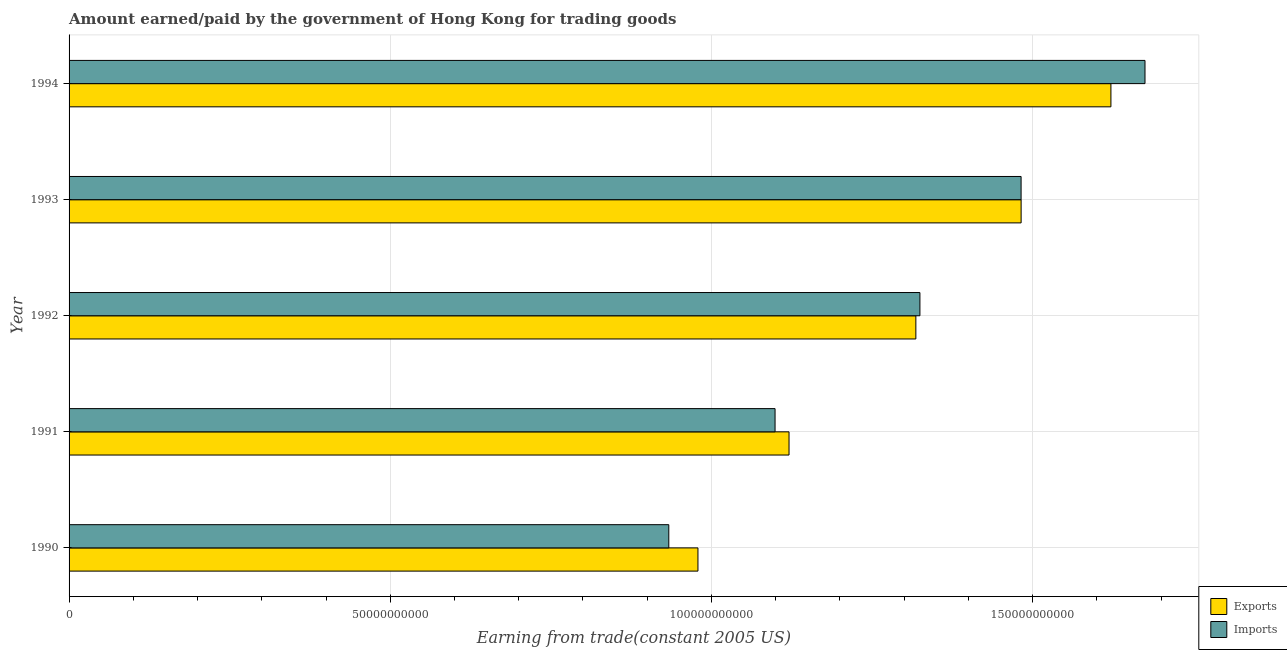How many different coloured bars are there?
Make the answer very short. 2. Are the number of bars on each tick of the Y-axis equal?
Give a very brief answer. Yes. How many bars are there on the 3rd tick from the top?
Give a very brief answer. 2. In how many cases, is the number of bars for a given year not equal to the number of legend labels?
Your answer should be compact. 0. What is the amount paid for imports in 1990?
Give a very brief answer. 9.34e+1. Across all years, what is the maximum amount paid for imports?
Offer a terse response. 1.67e+11. Across all years, what is the minimum amount earned from exports?
Provide a short and direct response. 9.79e+1. In which year was the amount paid for imports minimum?
Your answer should be very brief. 1990. What is the total amount paid for imports in the graph?
Provide a succinct answer. 6.51e+11. What is the difference between the amount paid for imports in 1990 and that in 1991?
Your response must be concise. -1.65e+1. What is the difference between the amount paid for imports in 1993 and the amount earned from exports in 1991?
Offer a very short reply. 3.61e+1. What is the average amount earned from exports per year?
Ensure brevity in your answer.  1.30e+11. In the year 1994, what is the difference between the amount paid for imports and amount earned from exports?
Your answer should be compact. 5.30e+09. What is the ratio of the amount paid for imports in 1990 to that in 1993?
Keep it short and to the point. 0.63. Is the amount earned from exports in 1992 less than that in 1994?
Your response must be concise. Yes. Is the difference between the amount paid for imports in 1992 and 1993 greater than the difference between the amount earned from exports in 1992 and 1993?
Offer a very short reply. Yes. What is the difference between the highest and the second highest amount paid for imports?
Make the answer very short. 1.93e+1. What is the difference between the highest and the lowest amount paid for imports?
Provide a short and direct response. 7.41e+1. In how many years, is the amount paid for imports greater than the average amount paid for imports taken over all years?
Offer a very short reply. 3. Is the sum of the amount paid for imports in 1990 and 1993 greater than the maximum amount earned from exports across all years?
Your answer should be very brief. Yes. What does the 2nd bar from the top in 1991 represents?
Your response must be concise. Exports. What does the 2nd bar from the bottom in 1990 represents?
Your answer should be compact. Imports. How many bars are there?
Keep it short and to the point. 10. Are all the bars in the graph horizontal?
Your answer should be compact. Yes. What is the difference between two consecutive major ticks on the X-axis?
Give a very brief answer. 5.00e+1. Are the values on the major ticks of X-axis written in scientific E-notation?
Ensure brevity in your answer.  No. Where does the legend appear in the graph?
Offer a very short reply. Bottom right. How are the legend labels stacked?
Your answer should be compact. Vertical. What is the title of the graph?
Your response must be concise. Amount earned/paid by the government of Hong Kong for trading goods. Does "Female" appear as one of the legend labels in the graph?
Keep it short and to the point. No. What is the label or title of the X-axis?
Your response must be concise. Earning from trade(constant 2005 US). What is the label or title of the Y-axis?
Provide a succinct answer. Year. What is the Earning from trade(constant 2005 US) in Exports in 1990?
Your answer should be very brief. 9.79e+1. What is the Earning from trade(constant 2005 US) in Imports in 1990?
Make the answer very short. 9.34e+1. What is the Earning from trade(constant 2005 US) in Exports in 1991?
Make the answer very short. 1.12e+11. What is the Earning from trade(constant 2005 US) in Imports in 1991?
Provide a succinct answer. 1.10e+11. What is the Earning from trade(constant 2005 US) in Exports in 1992?
Give a very brief answer. 1.32e+11. What is the Earning from trade(constant 2005 US) in Imports in 1992?
Your answer should be very brief. 1.32e+11. What is the Earning from trade(constant 2005 US) in Exports in 1993?
Offer a very short reply. 1.48e+11. What is the Earning from trade(constant 2005 US) of Imports in 1993?
Provide a short and direct response. 1.48e+11. What is the Earning from trade(constant 2005 US) of Exports in 1994?
Give a very brief answer. 1.62e+11. What is the Earning from trade(constant 2005 US) of Imports in 1994?
Your response must be concise. 1.67e+11. Across all years, what is the maximum Earning from trade(constant 2005 US) of Exports?
Your answer should be compact. 1.62e+11. Across all years, what is the maximum Earning from trade(constant 2005 US) in Imports?
Make the answer very short. 1.67e+11. Across all years, what is the minimum Earning from trade(constant 2005 US) of Exports?
Give a very brief answer. 9.79e+1. Across all years, what is the minimum Earning from trade(constant 2005 US) of Imports?
Make the answer very short. 9.34e+1. What is the total Earning from trade(constant 2005 US) in Exports in the graph?
Ensure brevity in your answer.  6.52e+11. What is the total Earning from trade(constant 2005 US) in Imports in the graph?
Your response must be concise. 6.51e+11. What is the difference between the Earning from trade(constant 2005 US) in Exports in 1990 and that in 1991?
Provide a succinct answer. -1.42e+1. What is the difference between the Earning from trade(constant 2005 US) in Imports in 1990 and that in 1991?
Make the answer very short. -1.65e+1. What is the difference between the Earning from trade(constant 2005 US) in Exports in 1990 and that in 1992?
Your answer should be very brief. -3.39e+1. What is the difference between the Earning from trade(constant 2005 US) of Imports in 1990 and that in 1992?
Make the answer very short. -3.91e+1. What is the difference between the Earning from trade(constant 2005 US) in Exports in 1990 and that in 1993?
Offer a terse response. -5.03e+1. What is the difference between the Earning from trade(constant 2005 US) in Imports in 1990 and that in 1993?
Provide a short and direct response. -5.48e+1. What is the difference between the Earning from trade(constant 2005 US) in Exports in 1990 and that in 1994?
Ensure brevity in your answer.  -6.43e+1. What is the difference between the Earning from trade(constant 2005 US) in Imports in 1990 and that in 1994?
Give a very brief answer. -7.41e+1. What is the difference between the Earning from trade(constant 2005 US) of Exports in 1991 and that in 1992?
Provide a short and direct response. -1.97e+1. What is the difference between the Earning from trade(constant 2005 US) in Imports in 1991 and that in 1992?
Offer a terse response. -2.25e+1. What is the difference between the Earning from trade(constant 2005 US) of Exports in 1991 and that in 1993?
Offer a very short reply. -3.61e+1. What is the difference between the Earning from trade(constant 2005 US) in Imports in 1991 and that in 1993?
Give a very brief answer. -3.83e+1. What is the difference between the Earning from trade(constant 2005 US) of Exports in 1991 and that in 1994?
Your answer should be compact. -5.01e+1. What is the difference between the Earning from trade(constant 2005 US) in Imports in 1991 and that in 1994?
Give a very brief answer. -5.76e+1. What is the difference between the Earning from trade(constant 2005 US) in Exports in 1992 and that in 1993?
Your answer should be very brief. -1.64e+1. What is the difference between the Earning from trade(constant 2005 US) in Imports in 1992 and that in 1993?
Your response must be concise. -1.57e+1. What is the difference between the Earning from trade(constant 2005 US) in Exports in 1992 and that in 1994?
Provide a short and direct response. -3.04e+1. What is the difference between the Earning from trade(constant 2005 US) in Imports in 1992 and that in 1994?
Ensure brevity in your answer.  -3.50e+1. What is the difference between the Earning from trade(constant 2005 US) of Exports in 1993 and that in 1994?
Offer a terse response. -1.40e+1. What is the difference between the Earning from trade(constant 2005 US) of Imports in 1993 and that in 1994?
Ensure brevity in your answer.  -1.93e+1. What is the difference between the Earning from trade(constant 2005 US) in Exports in 1990 and the Earning from trade(constant 2005 US) in Imports in 1991?
Your answer should be very brief. -1.20e+1. What is the difference between the Earning from trade(constant 2005 US) of Exports in 1990 and the Earning from trade(constant 2005 US) of Imports in 1992?
Give a very brief answer. -3.46e+1. What is the difference between the Earning from trade(constant 2005 US) of Exports in 1990 and the Earning from trade(constant 2005 US) of Imports in 1993?
Offer a terse response. -5.03e+1. What is the difference between the Earning from trade(constant 2005 US) in Exports in 1990 and the Earning from trade(constant 2005 US) in Imports in 1994?
Offer a terse response. -6.96e+1. What is the difference between the Earning from trade(constant 2005 US) in Exports in 1991 and the Earning from trade(constant 2005 US) in Imports in 1992?
Offer a very short reply. -2.04e+1. What is the difference between the Earning from trade(constant 2005 US) in Exports in 1991 and the Earning from trade(constant 2005 US) in Imports in 1993?
Keep it short and to the point. -3.61e+1. What is the difference between the Earning from trade(constant 2005 US) in Exports in 1991 and the Earning from trade(constant 2005 US) in Imports in 1994?
Provide a short and direct response. -5.54e+1. What is the difference between the Earning from trade(constant 2005 US) in Exports in 1992 and the Earning from trade(constant 2005 US) in Imports in 1993?
Provide a short and direct response. -1.64e+1. What is the difference between the Earning from trade(constant 2005 US) in Exports in 1992 and the Earning from trade(constant 2005 US) in Imports in 1994?
Your answer should be very brief. -3.57e+1. What is the difference between the Earning from trade(constant 2005 US) of Exports in 1993 and the Earning from trade(constant 2005 US) of Imports in 1994?
Provide a short and direct response. -1.93e+1. What is the average Earning from trade(constant 2005 US) of Exports per year?
Keep it short and to the point. 1.30e+11. What is the average Earning from trade(constant 2005 US) in Imports per year?
Ensure brevity in your answer.  1.30e+11. In the year 1990, what is the difference between the Earning from trade(constant 2005 US) of Exports and Earning from trade(constant 2005 US) of Imports?
Provide a short and direct response. 4.54e+09. In the year 1991, what is the difference between the Earning from trade(constant 2005 US) of Exports and Earning from trade(constant 2005 US) of Imports?
Provide a short and direct response. 2.17e+09. In the year 1992, what is the difference between the Earning from trade(constant 2005 US) in Exports and Earning from trade(constant 2005 US) in Imports?
Your response must be concise. -6.32e+08. In the year 1993, what is the difference between the Earning from trade(constant 2005 US) in Exports and Earning from trade(constant 2005 US) in Imports?
Keep it short and to the point. 4.68e+06. In the year 1994, what is the difference between the Earning from trade(constant 2005 US) in Exports and Earning from trade(constant 2005 US) in Imports?
Give a very brief answer. -5.30e+09. What is the ratio of the Earning from trade(constant 2005 US) of Exports in 1990 to that in 1991?
Provide a succinct answer. 0.87. What is the ratio of the Earning from trade(constant 2005 US) in Imports in 1990 to that in 1991?
Provide a succinct answer. 0.85. What is the ratio of the Earning from trade(constant 2005 US) in Exports in 1990 to that in 1992?
Your answer should be compact. 0.74. What is the ratio of the Earning from trade(constant 2005 US) of Imports in 1990 to that in 1992?
Offer a very short reply. 0.7. What is the ratio of the Earning from trade(constant 2005 US) in Exports in 1990 to that in 1993?
Provide a succinct answer. 0.66. What is the ratio of the Earning from trade(constant 2005 US) in Imports in 1990 to that in 1993?
Keep it short and to the point. 0.63. What is the ratio of the Earning from trade(constant 2005 US) in Exports in 1990 to that in 1994?
Provide a short and direct response. 0.6. What is the ratio of the Earning from trade(constant 2005 US) in Imports in 1990 to that in 1994?
Your answer should be very brief. 0.56. What is the ratio of the Earning from trade(constant 2005 US) of Exports in 1991 to that in 1992?
Make the answer very short. 0.85. What is the ratio of the Earning from trade(constant 2005 US) of Imports in 1991 to that in 1992?
Provide a succinct answer. 0.83. What is the ratio of the Earning from trade(constant 2005 US) in Exports in 1991 to that in 1993?
Offer a terse response. 0.76. What is the ratio of the Earning from trade(constant 2005 US) of Imports in 1991 to that in 1993?
Your answer should be very brief. 0.74. What is the ratio of the Earning from trade(constant 2005 US) of Exports in 1991 to that in 1994?
Keep it short and to the point. 0.69. What is the ratio of the Earning from trade(constant 2005 US) in Imports in 1991 to that in 1994?
Your response must be concise. 0.66. What is the ratio of the Earning from trade(constant 2005 US) of Exports in 1992 to that in 1993?
Your response must be concise. 0.89. What is the ratio of the Earning from trade(constant 2005 US) of Imports in 1992 to that in 1993?
Provide a succinct answer. 0.89. What is the ratio of the Earning from trade(constant 2005 US) of Exports in 1992 to that in 1994?
Provide a short and direct response. 0.81. What is the ratio of the Earning from trade(constant 2005 US) of Imports in 1992 to that in 1994?
Offer a terse response. 0.79. What is the ratio of the Earning from trade(constant 2005 US) of Exports in 1993 to that in 1994?
Your answer should be very brief. 0.91. What is the ratio of the Earning from trade(constant 2005 US) in Imports in 1993 to that in 1994?
Offer a terse response. 0.88. What is the difference between the highest and the second highest Earning from trade(constant 2005 US) in Exports?
Your answer should be very brief. 1.40e+1. What is the difference between the highest and the second highest Earning from trade(constant 2005 US) in Imports?
Your answer should be compact. 1.93e+1. What is the difference between the highest and the lowest Earning from trade(constant 2005 US) in Exports?
Your response must be concise. 6.43e+1. What is the difference between the highest and the lowest Earning from trade(constant 2005 US) of Imports?
Your answer should be compact. 7.41e+1. 